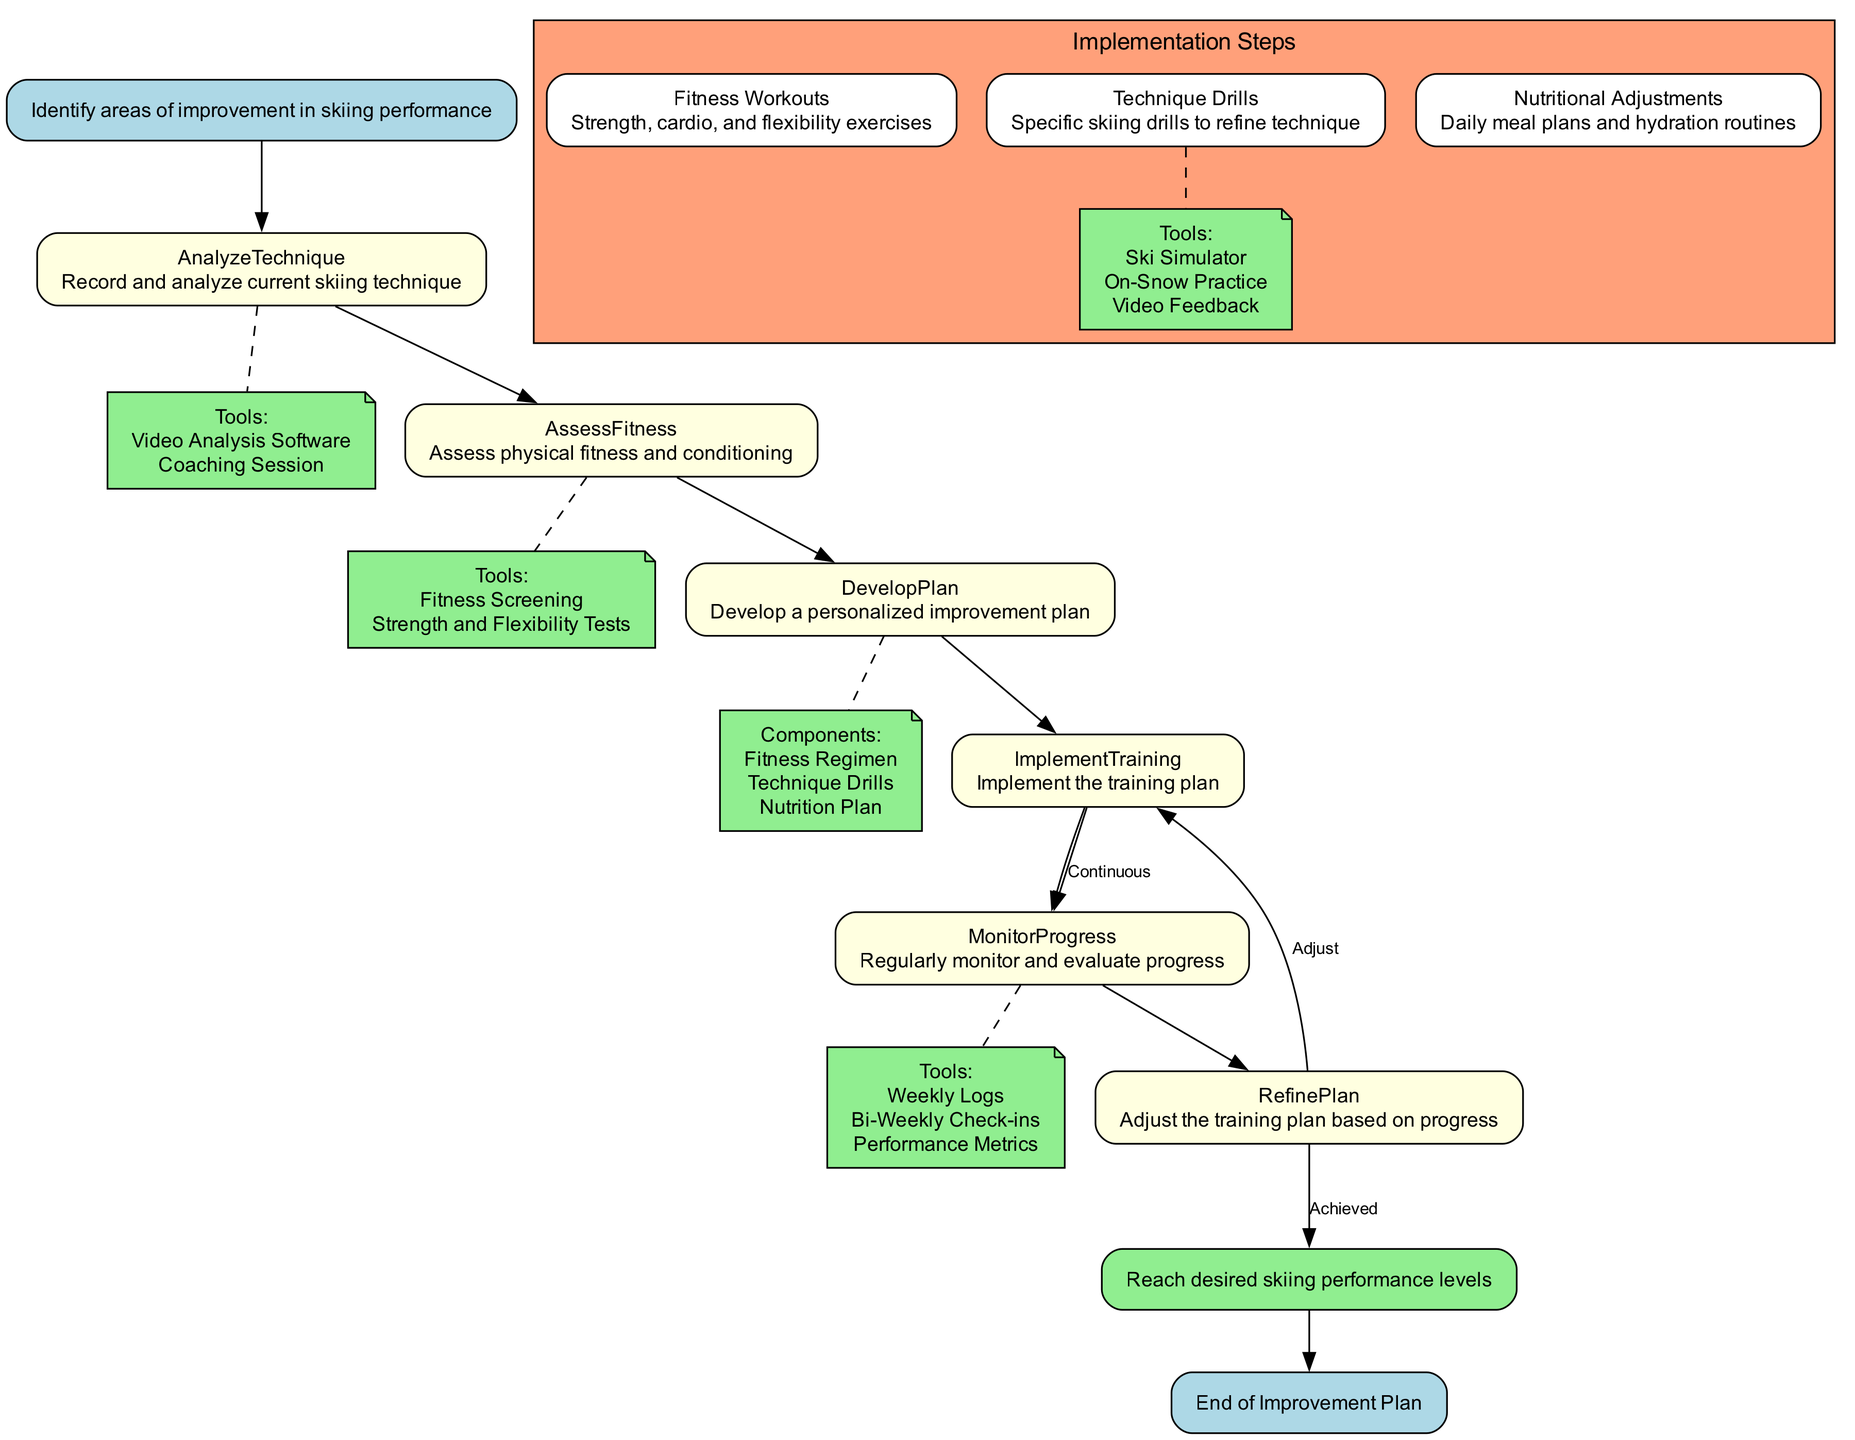What is the first step in the improvement plan? The improvement plan starts with identifying areas of improvement in skiing performance. This is indicated as the 'Start' node in the diagram, establishing the initial action.
Answer: Identify areas of improvement in skiing performance How many main process nodes are there? By examining the structured flow of the diagram, there are six main process nodes: AnalyzeTechnique, AssessFitness, DevelopPlan, ImplementTraining, MonitorProgress, and RefinePlan. Thus, the total is six.
Answer: 6 Which action follows 'ImplementTraining'? After the 'ImplementTraining' action, the next step is 'MonitorProgress'. This is shown in the diagram as a direct edge connecting these two action nodes.
Answer: Monitor Progress What tools are mentioned in assessing fitness? In the AssessFitness node, the tools listed are Fitness Screening and Strength and Flexibility Tests, which can be extracted directly from the 'tools' attribute of that node in the diagram.
Answer: Fitness Screening, Strength and Flexibility Tests What components are included in the development plan? The components of the personalized improvement plan include Fitness Regimen, Technique Drills, and Nutrition Plan, all of which are specifically noted under the DevelopPlan node as the plan components.
Answer: Fitness Regimen, Technique Drills, Nutrition Plan What is the purpose of the 'RefinePlan' step? The purpose of the 'RefinePlan' step is to adjust the training plan based on progress. This action is explicitly stated in the node attributes, reflecting the need for ongoing evaluation and adaptation.
Answer: Adjust the training plan based on progress What is indicated by the dashed edges in the diagram? The dashed edges in the diagram indicate supportive or supplementary information connecting the main nodes to tools or components, emphasizing their significance without being the primary actions themselves.
Answer: Tools or Components What is the last step before ending the improvement plan? Before reaching the end of the improvement plan, the last step is 'GoalAchievement', which directly follows and signifies achieving the desired skiing performance levels as outlined in the flow of the diagram.
Answer: Goal Achievement How do the 'ImplementTraining' and 'MonitorProgress' steps relate? The 'ImplementTraining' step leads to 'MonitorProgress' indicating a continuous evaluation process where the implementation of the training plan is closely monitored, reflecting an essential feedback loop in the training regimen.
Answer: Continuous evaluation process 